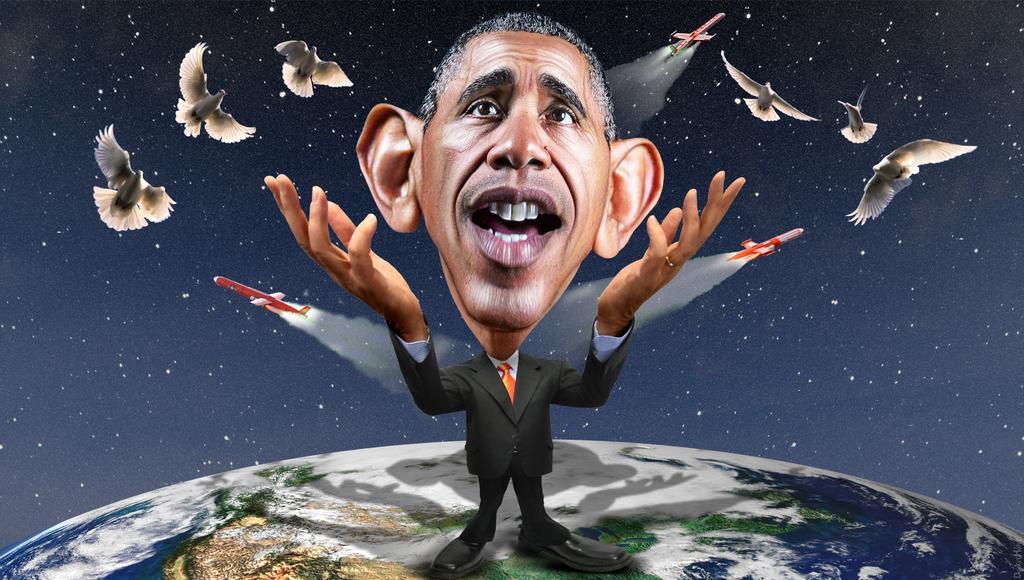In one or two sentences, can you explain what this image depicts? This looks like an edited image. This is the man standing on the earth. These are the birds and the aircrafts flying in the sky. I can see the stars. 